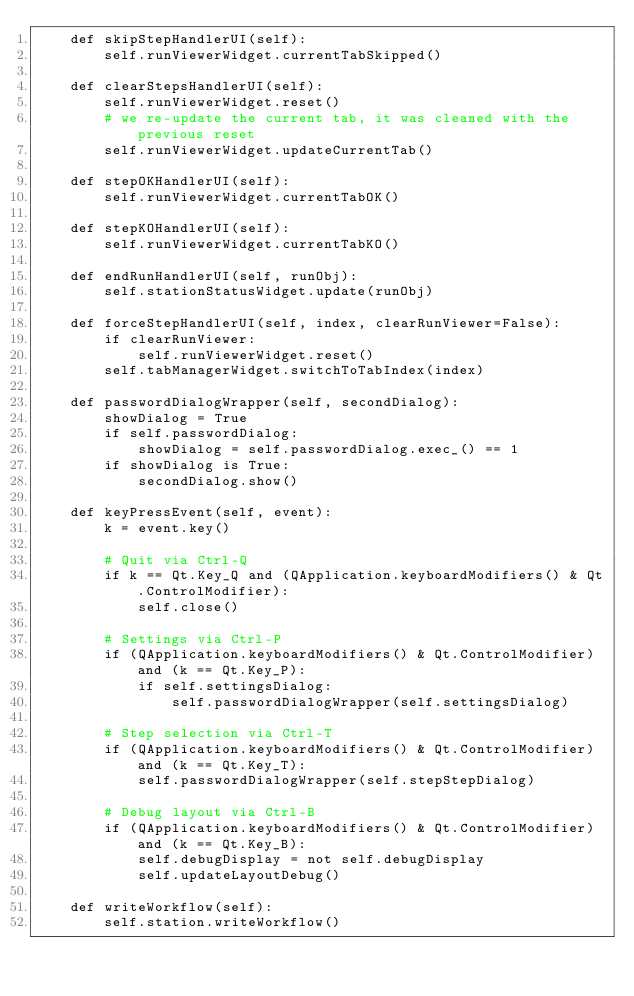<code> <loc_0><loc_0><loc_500><loc_500><_Python_>    def skipStepHandlerUI(self):
        self.runViewerWidget.currentTabSkipped()

    def clearStepsHandlerUI(self):
        self.runViewerWidget.reset()
        # we re-update the current tab, it was cleaned with the previous reset
        self.runViewerWidget.updateCurrentTab()

    def stepOKHandlerUI(self):
        self.runViewerWidget.currentTabOK()

    def stepKOHandlerUI(self):
        self.runViewerWidget.currentTabKO()

    def endRunHandlerUI(self, runObj):
        self.stationStatusWidget.update(runObj)

    def forceStepHandlerUI(self, index, clearRunViewer=False):
        if clearRunViewer:
            self.runViewerWidget.reset()
        self.tabManagerWidget.switchToTabIndex(index)

    def passwordDialogWrapper(self, secondDialog):
        showDialog = True
        if self.passwordDialog:
            showDialog = self.passwordDialog.exec_() == 1
        if showDialog is True:
            secondDialog.show()

    def keyPressEvent(self, event):
        k = event.key()

        # Quit via Ctrl-Q
        if k == Qt.Key_Q and (QApplication.keyboardModifiers() & Qt.ControlModifier):
            self.close()

        # Settings via Ctrl-P
        if (QApplication.keyboardModifiers() & Qt.ControlModifier) and (k == Qt.Key_P):
            if self.settingsDialog:
                self.passwordDialogWrapper(self.settingsDialog)

        # Step selection via Ctrl-T
        if (QApplication.keyboardModifiers() & Qt.ControlModifier) and (k == Qt.Key_T):
            self.passwordDialogWrapper(self.stepStepDialog)

        # Debug layout via Ctrl-B
        if (QApplication.keyboardModifiers() & Qt.ControlModifier) and (k == Qt.Key_B):
            self.debugDisplay = not self.debugDisplay
            self.updateLayoutDebug()

    def writeWorkflow(self):
        self.station.writeWorkflow()
</code> 